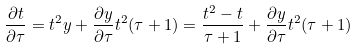<formula> <loc_0><loc_0><loc_500><loc_500>\frac { \partial t } { \partial \tau } = t ^ { 2 } y + \frac { \partial y } { \partial \tau } t ^ { 2 } ( \tau + 1 ) = \frac { t ^ { 2 } - t } { \tau + 1 } + \frac { \partial y } { \partial \tau } t ^ { 2 } ( \tau + 1 )</formula> 